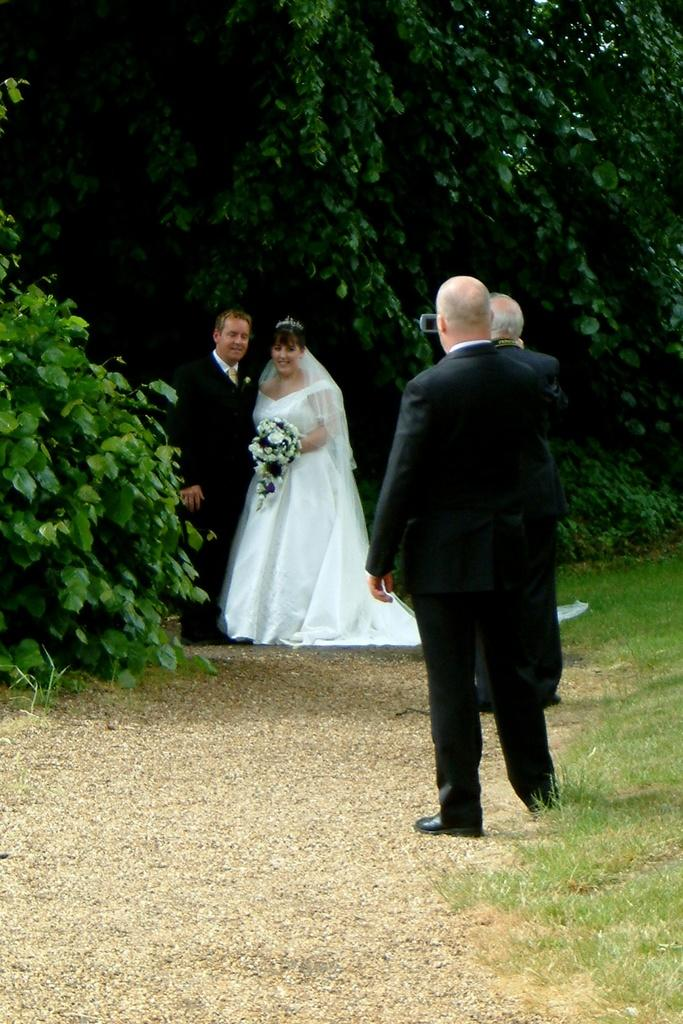How many people are in the image? There are two persons in the image, a man and a woman. What are the people in the image doing? Both the man and woman are standing and smiling. Who is holding a bouquet in the image? There is a woman holding a bouquet in the image. What can be seen in the background of the image? There are trees in the background of the image. What type of bottle is visible on the top of the man's head in the image? There is no bottle visible on the top of the man's head in the image. 